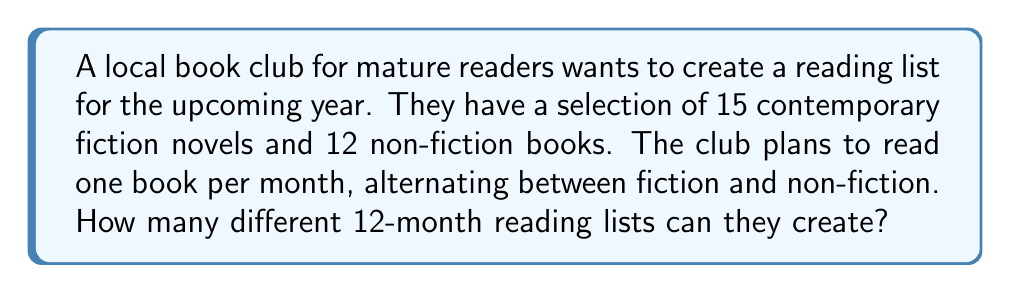Help me with this question. Let's break this down step-by-step:

1) The club needs to select 6 fiction books and 6 non-fiction books for a total of 12 books.

2) For the fiction selections:
   - We need to choose 6 books out of 15
   - This is a combination problem, represented as $\binom{15}{6}$
   - The formula for this combination is:
     $$\binom{15}{6} = \frac{15!}{6!(15-6)!} = \frac{15!}{6!9!} = 5005$$

3) For the non-fiction selections:
   - We need to choose 6 books out of 12
   - This is represented as $\binom{12}{6}$
   - The formula for this combination is:
     $$\binom{12}{6} = \frac{12!}{6!(12-6)!} = \frac{12!}{6!6!} = 924$$

4) Now, for each selection of fiction books, we can have any selection of non-fiction books. Therefore, we multiply these numbers:

   $$5005 \times 924 = 4,624,620$$

5) However, this only accounts for the selection of books, not their order. The question asks for different reading lists, which implies order matters.

6) For each selection of 12 books, we can arrange them in $6! = 720$ ways (because we're alternating fiction and non-fiction, so we only need to arrange 6 positions).

7) Therefore, the final number of possible reading lists is:

   $$4,624,620 \times 720 = 3,329,726,400$$
Answer: 3,329,726,400 